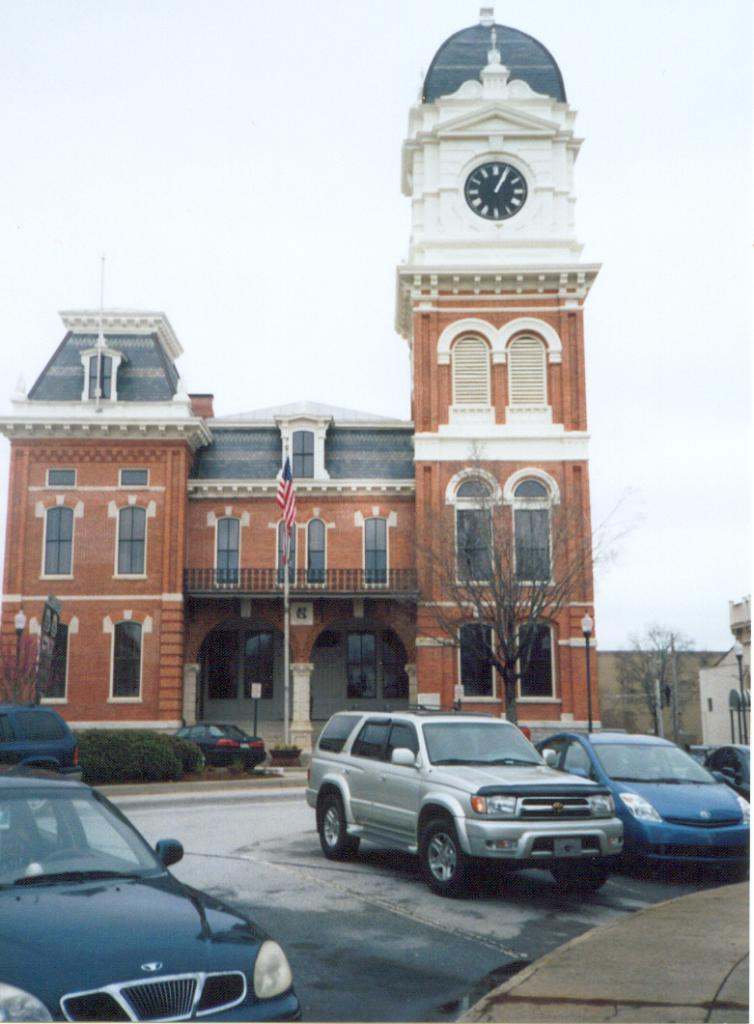What can be seen in the foreground of the image? There are vehicles in the foreground of the image. What type of structures are present in the image? There are lamp poles, trees, and buildings visible in the image. What is visible in the background of the image? The sky is visible in the background of the image. What type of haircut is being given to the trees in the image? There is no haircut being given to the trees in the image; they are natural trees. What degree of difficulty is required to climb the lamp poles in the image? There is no indication of the difficulty level for climbing the lamp poles in the image, and it is not recommended to attempt climbing them. 